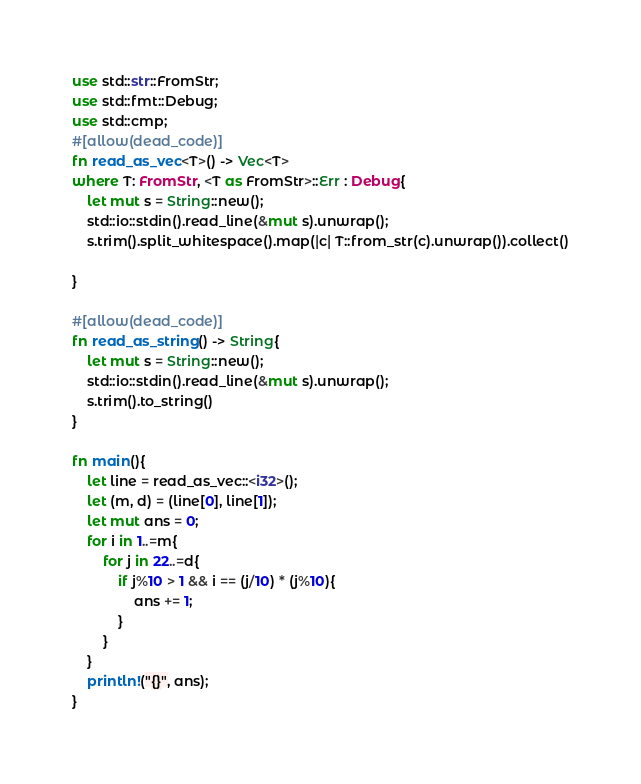<code> <loc_0><loc_0><loc_500><loc_500><_Rust_>use std::str::FromStr;
use std::fmt::Debug;
use std::cmp;
#[allow(dead_code)]
fn read_as_vec<T>() -> Vec<T>
where T: FromStr, <T as FromStr>::Err : Debug{
    let mut s = String::new();
    std::io::stdin().read_line(&mut s).unwrap();
    s.trim().split_whitespace().map(|c| T::from_str(c).unwrap()).collect()

}

#[allow(dead_code)]
fn read_as_string() -> String{
    let mut s = String::new();
    std::io::stdin().read_line(&mut s).unwrap();
    s.trim().to_string()
}

fn main(){
    let line = read_as_vec::<i32>();
    let (m, d) = (line[0], line[1]);
    let mut ans = 0;
    for i in 1..=m{
        for j in 22..=d{
            if j%10 > 1 && i == (j/10) * (j%10){
                ans += 1;
            }
        }
    }
    println!("{}", ans);
}
</code> 